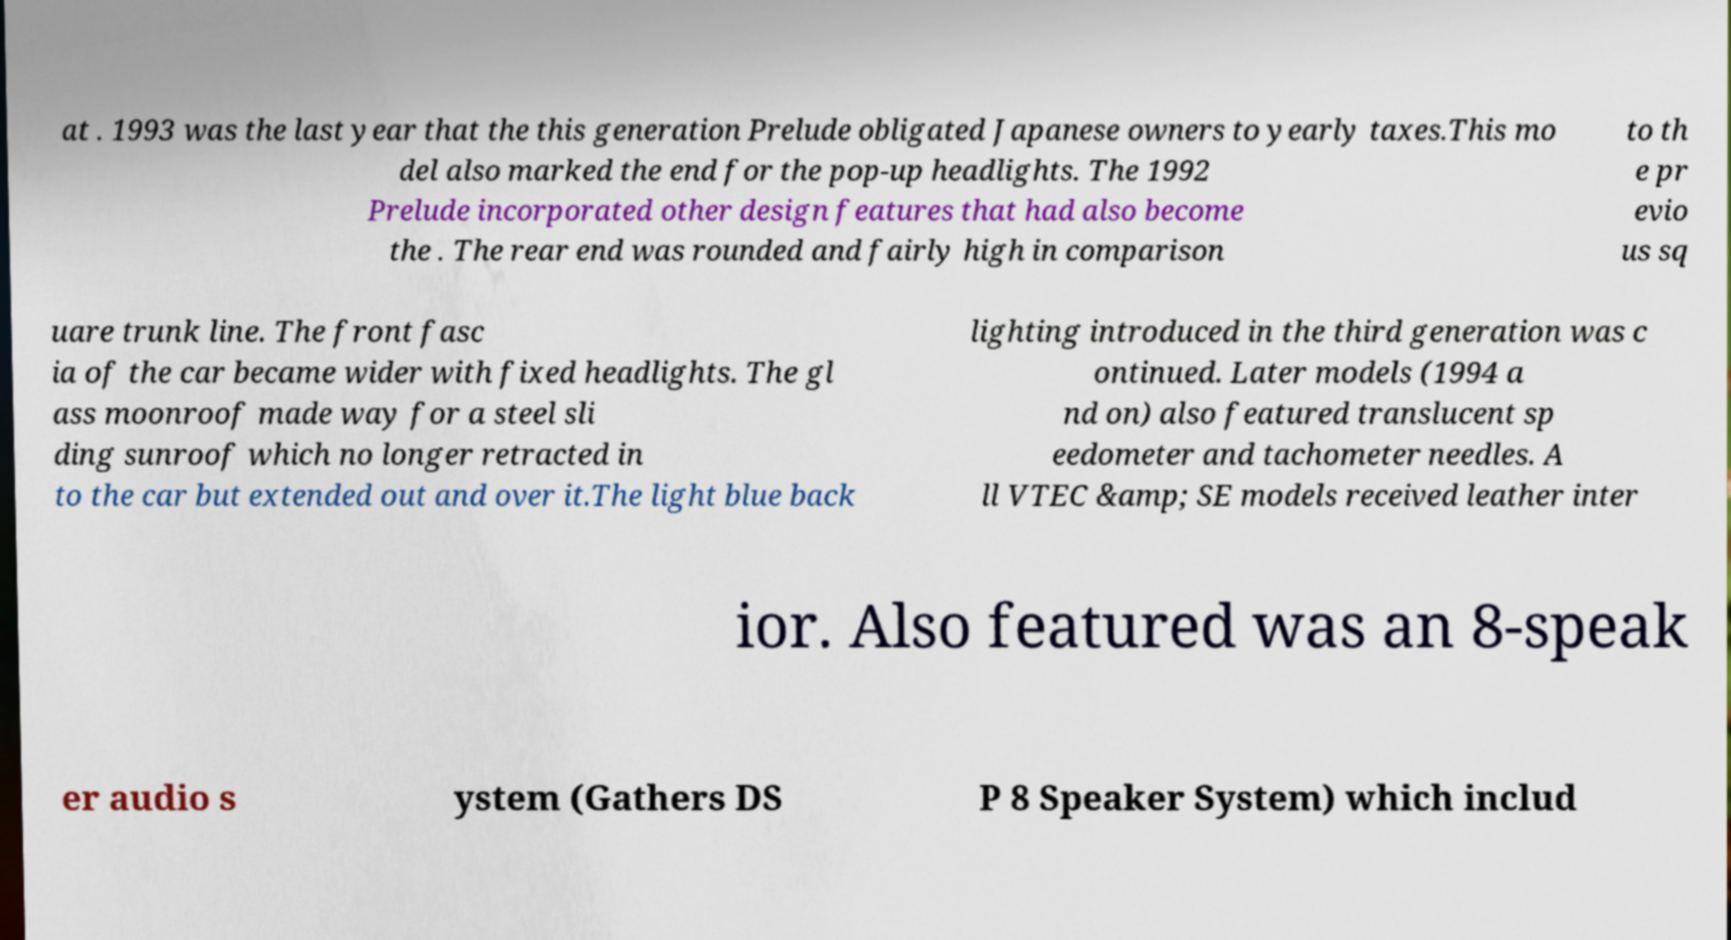For documentation purposes, I need the text within this image transcribed. Could you provide that? at . 1993 was the last year that the this generation Prelude obligated Japanese owners to yearly taxes.This mo del also marked the end for the pop-up headlights. The 1992 Prelude incorporated other design features that had also become the . The rear end was rounded and fairly high in comparison to th e pr evio us sq uare trunk line. The front fasc ia of the car became wider with fixed headlights. The gl ass moonroof made way for a steel sli ding sunroof which no longer retracted in to the car but extended out and over it.The light blue back lighting introduced in the third generation was c ontinued. Later models (1994 a nd on) also featured translucent sp eedometer and tachometer needles. A ll VTEC &amp; SE models received leather inter ior. Also featured was an 8-speak er audio s ystem (Gathers DS P 8 Speaker System) which includ 